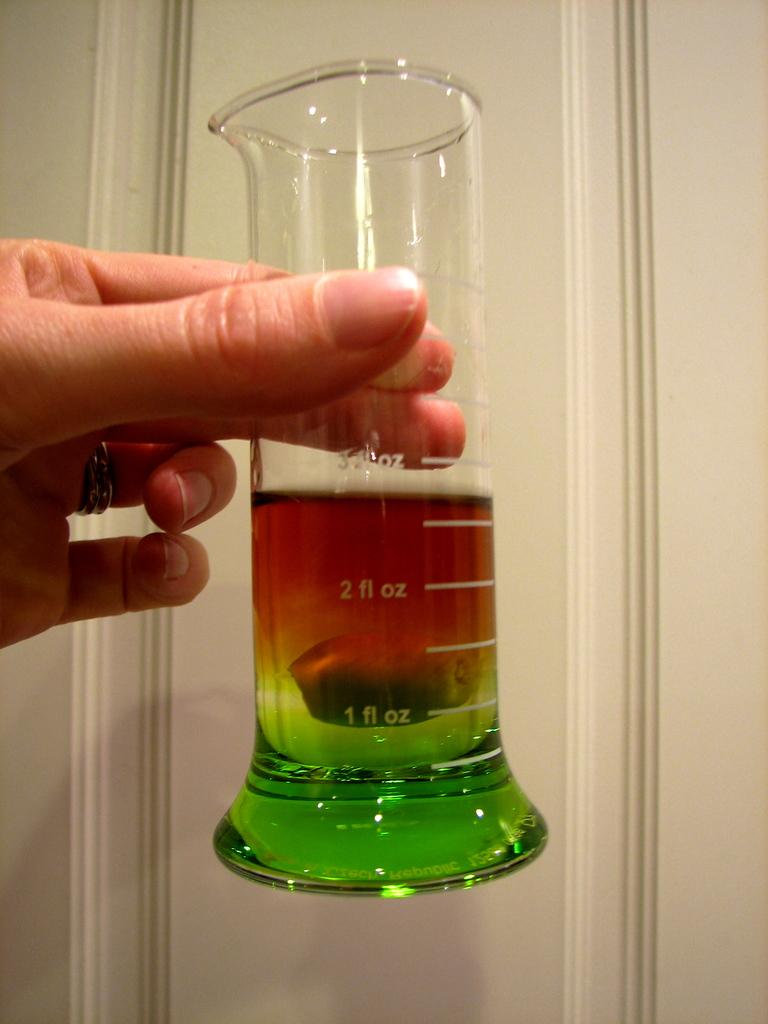<image>
Present a compact description of the photo's key features. The liquid measures 2.75 fl oz in the container. 